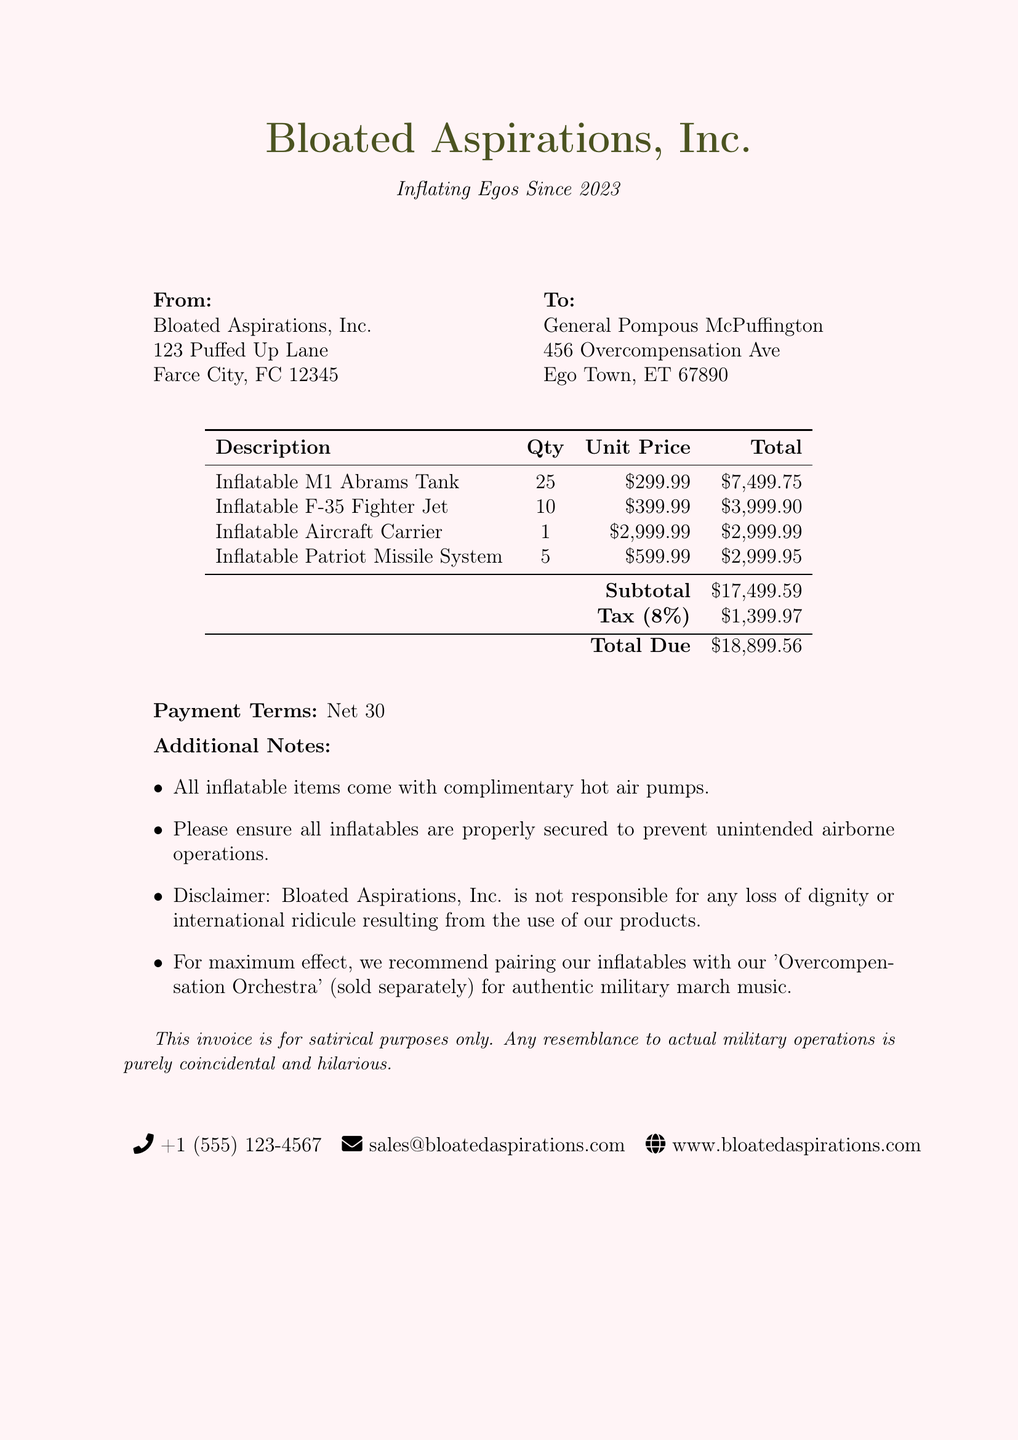What is the invoice number? The invoice number is recorded in the document as a unique identifier for this transaction.
Answer: INF-2023-0042 When was the invoice issued? The date issued is important for understanding the payment schedule and deadlines associated with the transaction.
Answer: 2023-05-15 What is the total amount due? The total due reflects the complete charge after subtotal and tax, which is crucial for payment purposes.
Answer: 18899.56 Who is the client? The client is identified to show who is responsible for the payment and associated dealings in this transaction.
Answer: General Pompous McPuffington What is the tax rate applied? Understanding the tax rate provides insight into the additional costs involved in the transaction.
Answer: 8% How many inflatable M1 Abrams Tanks are included? The quantity of specific items helps assess the scale of the purchase made for the parade.
Answer: 25 What additional item is recommended for maximum effect? This reflects the company's upselling strategy and the intended user experience with the products.
Answer: Overcompensation Orchestra What is the due date for payment? The due date indicates when the payment is expected, key for accounting and budgeting purposes.
Answer: 2023-06-15 What does the disclaimer in the document state? The disclaimer provides context on the nature of the invoice, indicating that it's satirical rather than serious.
Answer: This invoice is for satirical purposes only 